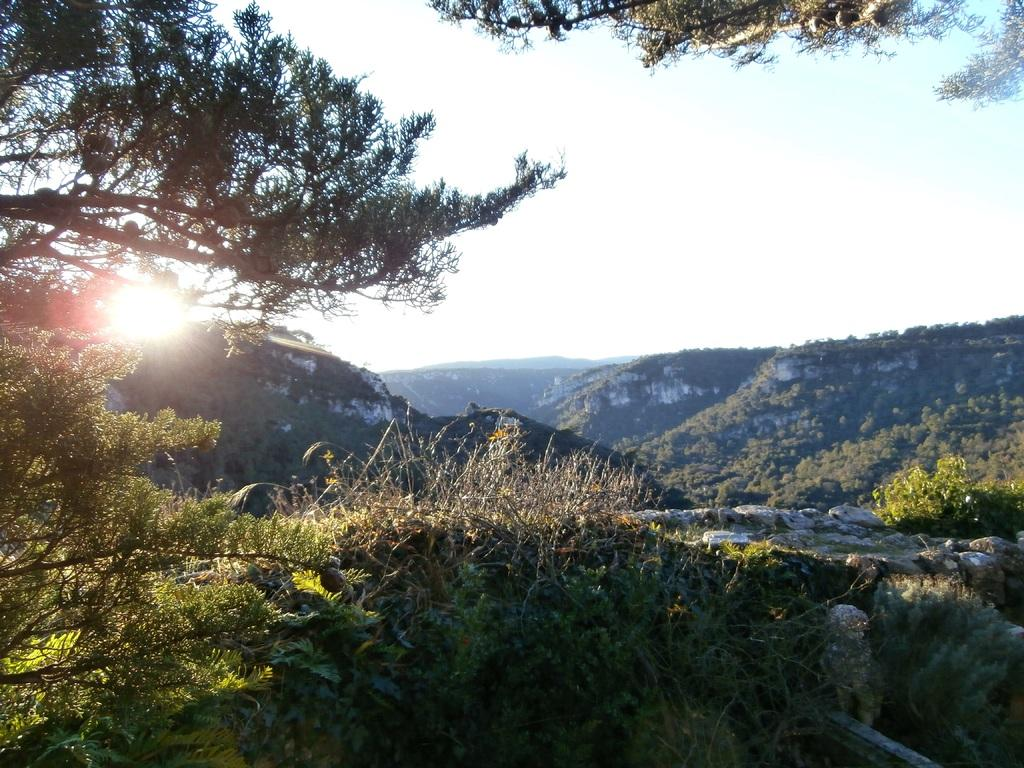What type of natural elements can be seen in the image? There are trees and mountains in the image. What is the source of light in the background of the image? Sunlight is visible in the background of the image. Where is the nearest shop located in the image? There is no shop present in the image; it features natural elements such as trees and mountains. 